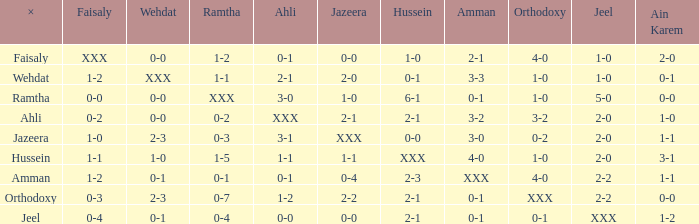What can ramtha be when jeel registers 1-0 and hussein records 1-0? 1-2. 